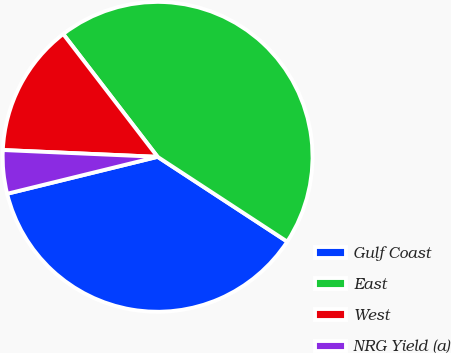<chart> <loc_0><loc_0><loc_500><loc_500><pie_chart><fcel>Gulf Coast<fcel>East<fcel>West<fcel>NRG Yield (a)<nl><fcel>36.95%<fcel>44.65%<fcel>13.87%<fcel>4.53%<nl></chart> 